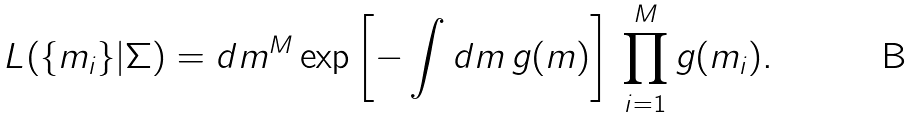<formula> <loc_0><loc_0><loc_500><loc_500>L ( \{ m _ { i } \} | \Sigma ) = d m ^ { M } \exp \left [ - \int d m \, g ( m ) \right ] \, \prod _ { i = 1 } ^ { M } g ( m _ { i } ) .</formula> 